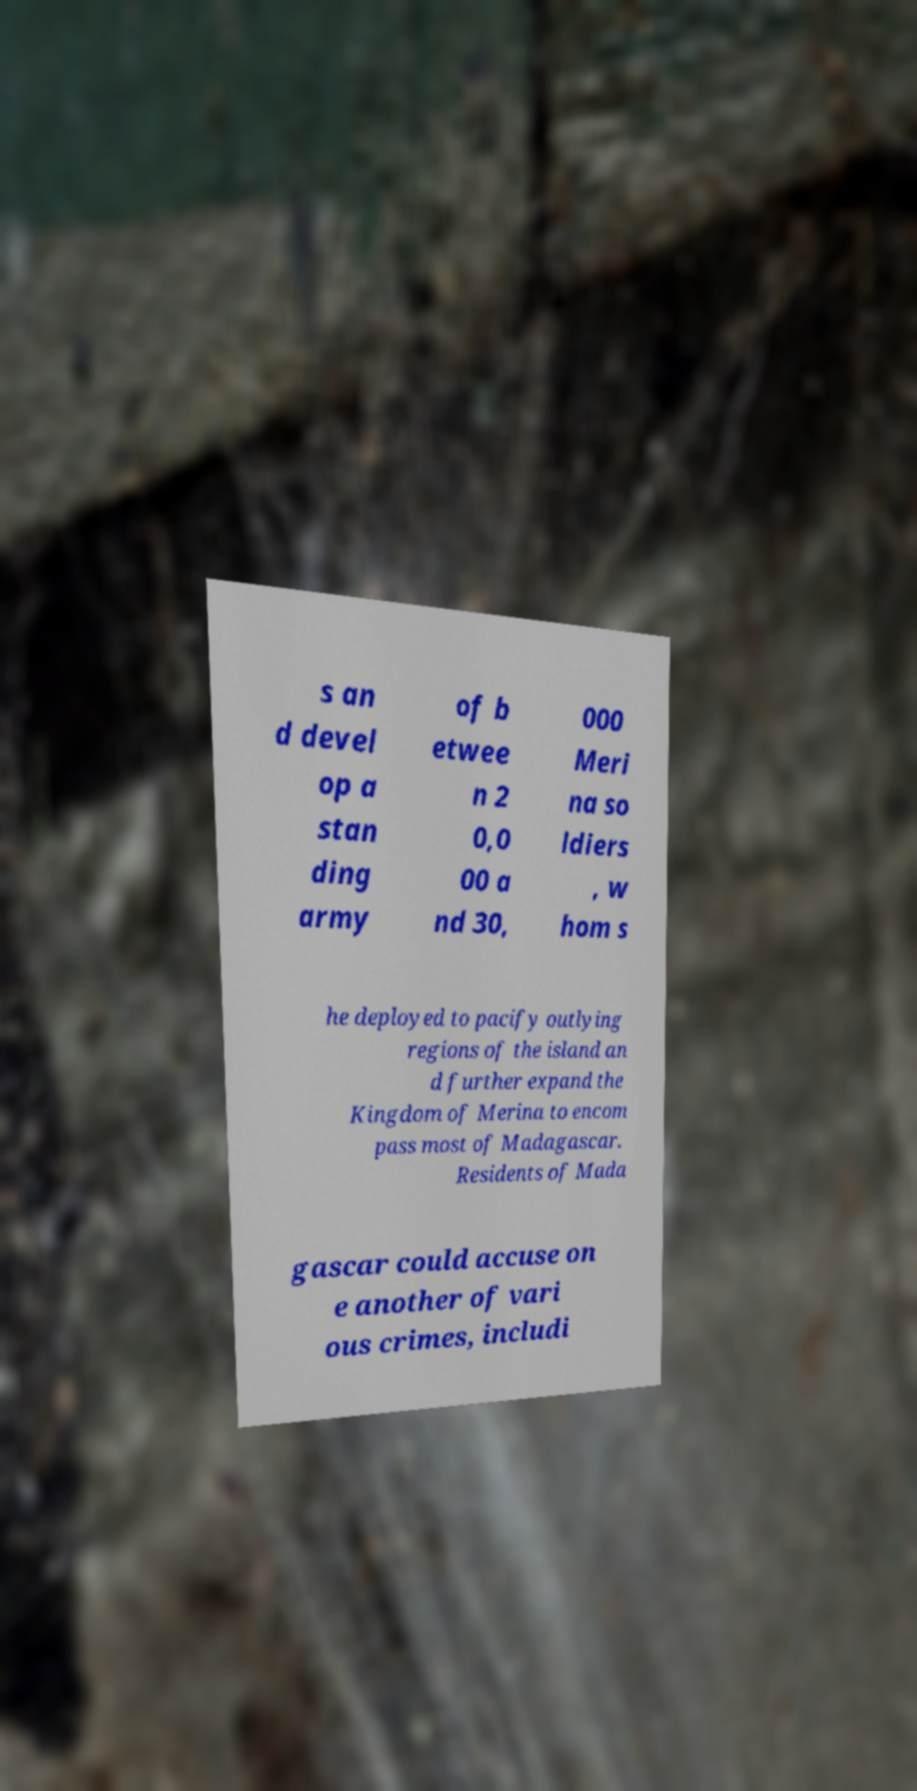Can you accurately transcribe the text from the provided image for me? s an d devel op a stan ding army of b etwee n 2 0,0 00 a nd 30, 000 Meri na so ldiers , w hom s he deployed to pacify outlying regions of the island an d further expand the Kingdom of Merina to encom pass most of Madagascar. Residents of Mada gascar could accuse on e another of vari ous crimes, includi 